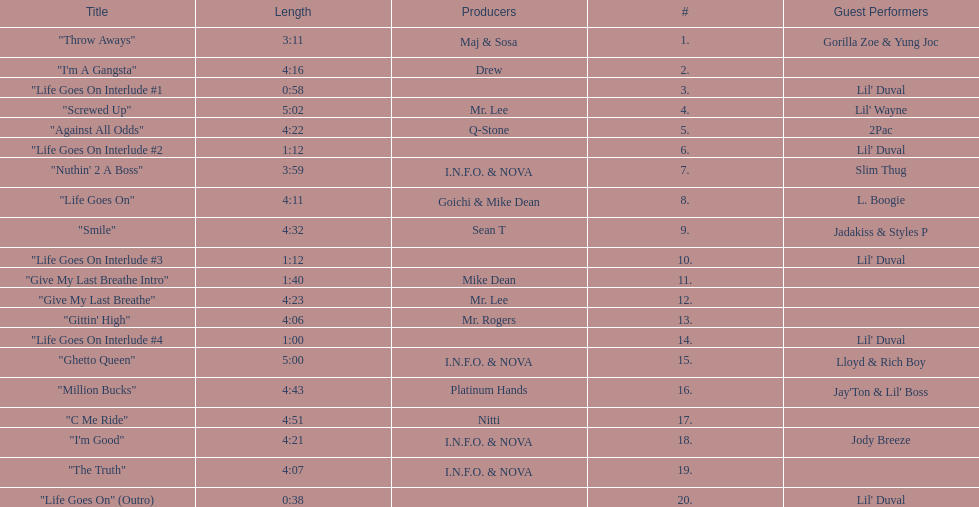What is the number of tracks featuring 2pac? 1. 